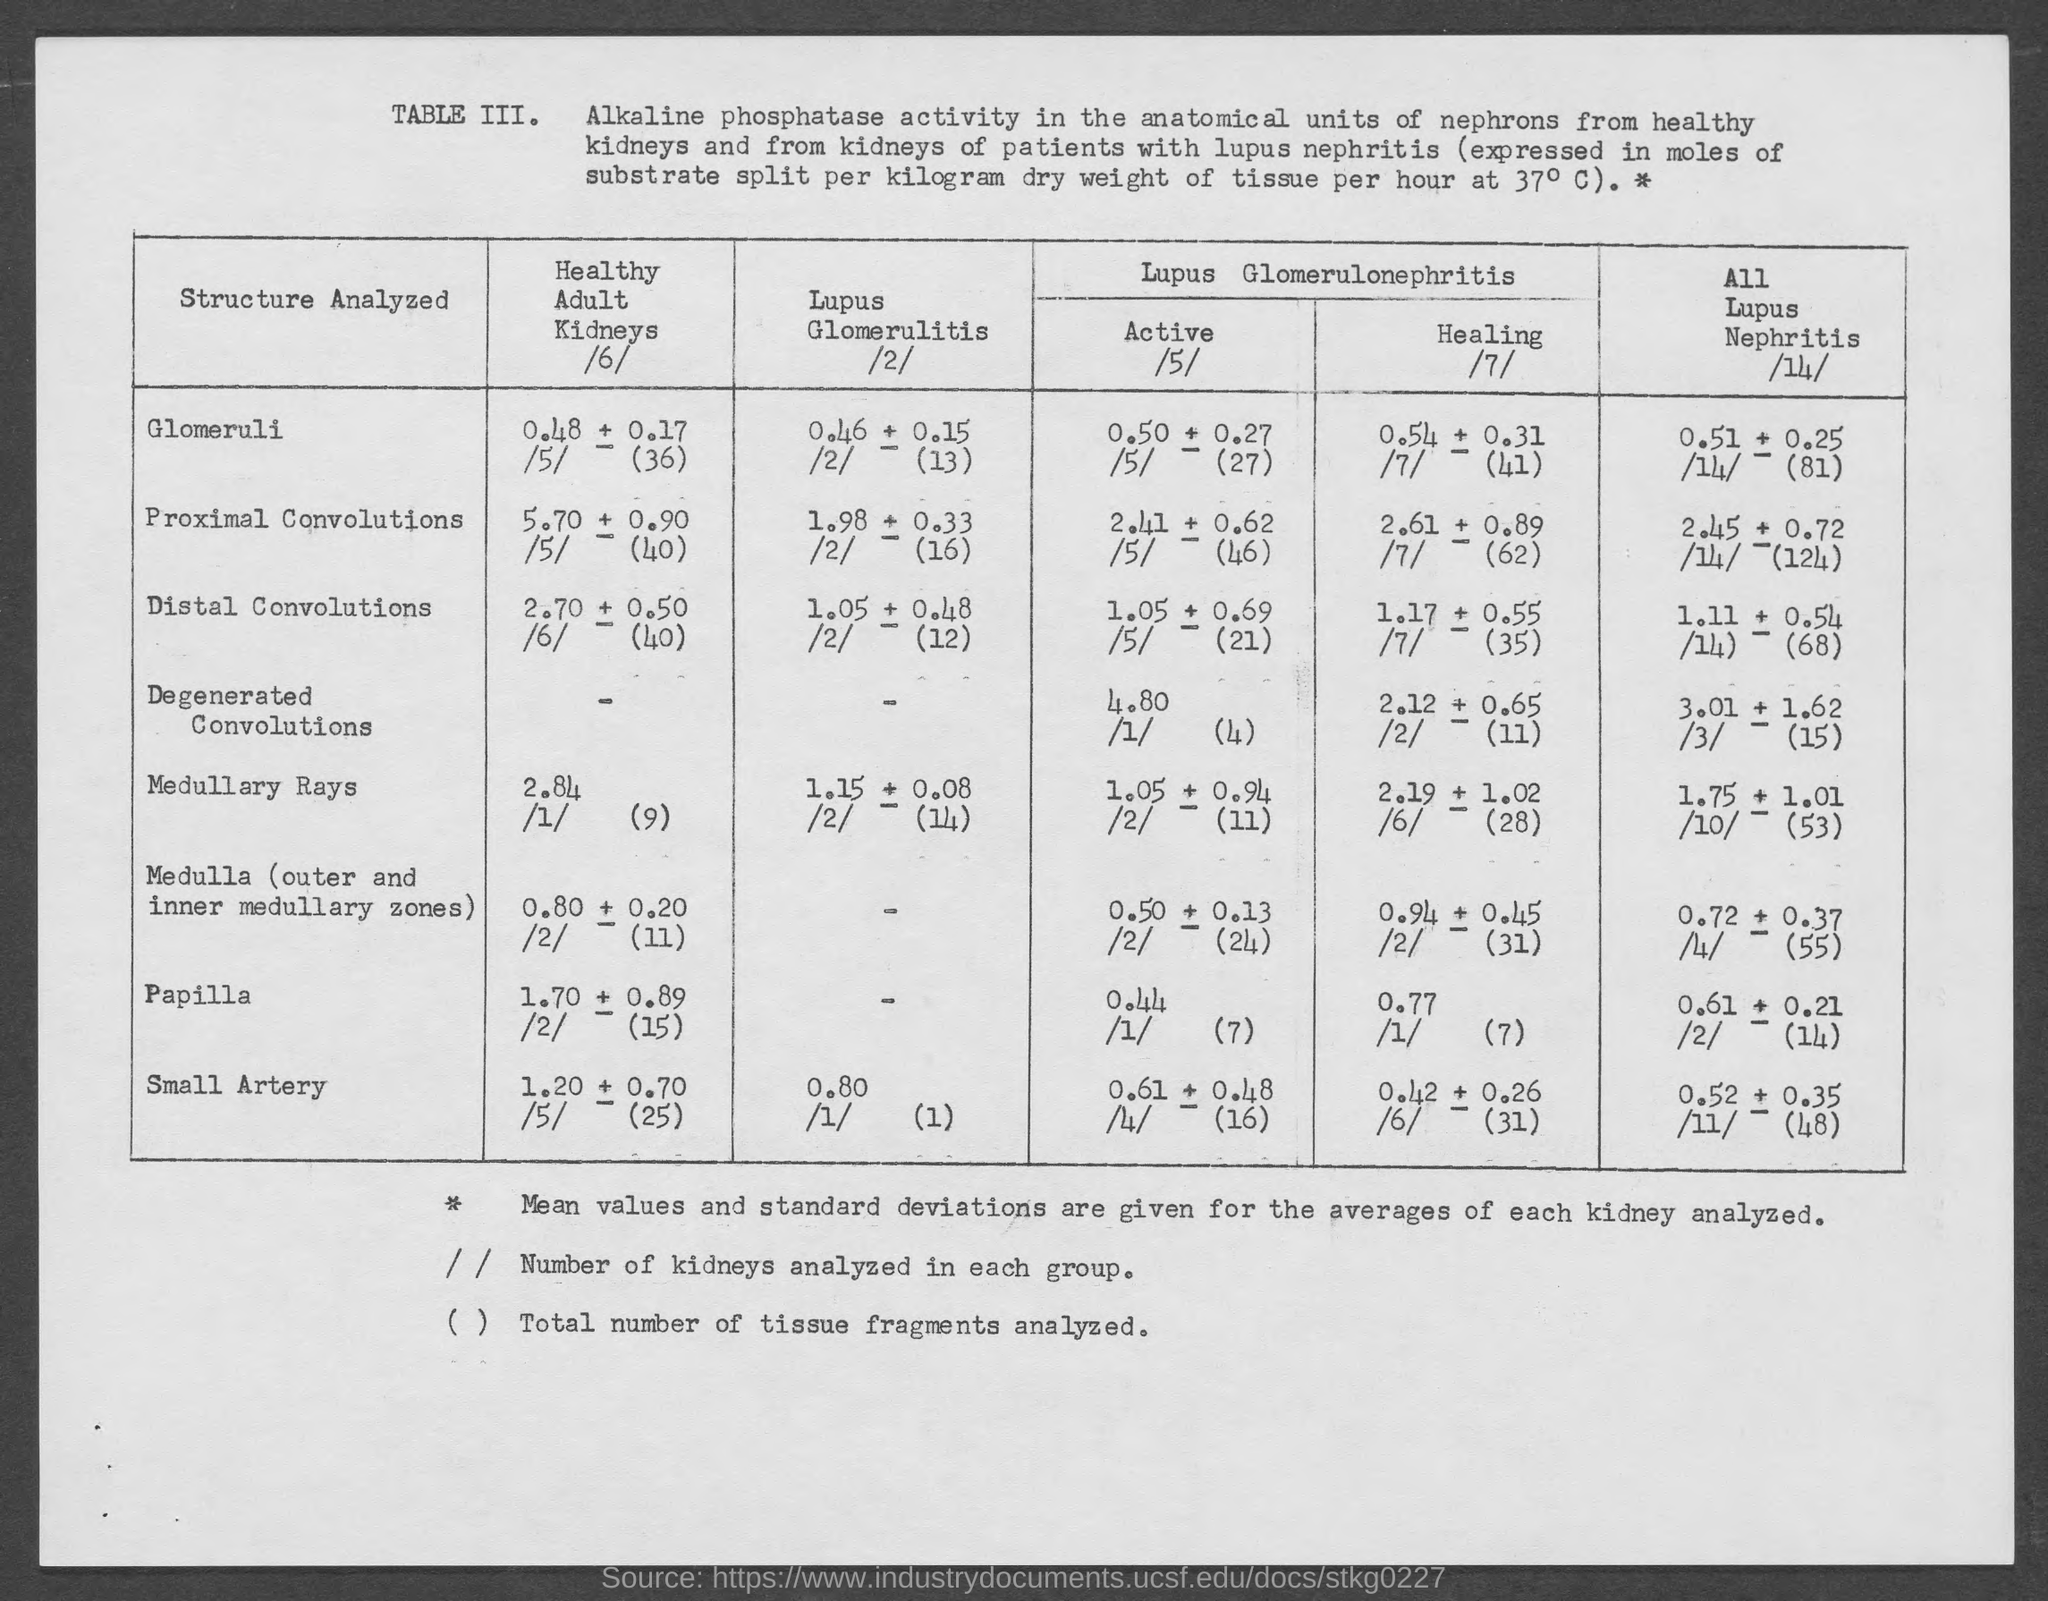Indicate a few pertinent items in this graphic. The value of Lupus Glomerulitis for a small artery structure analyzed is 0.80. 